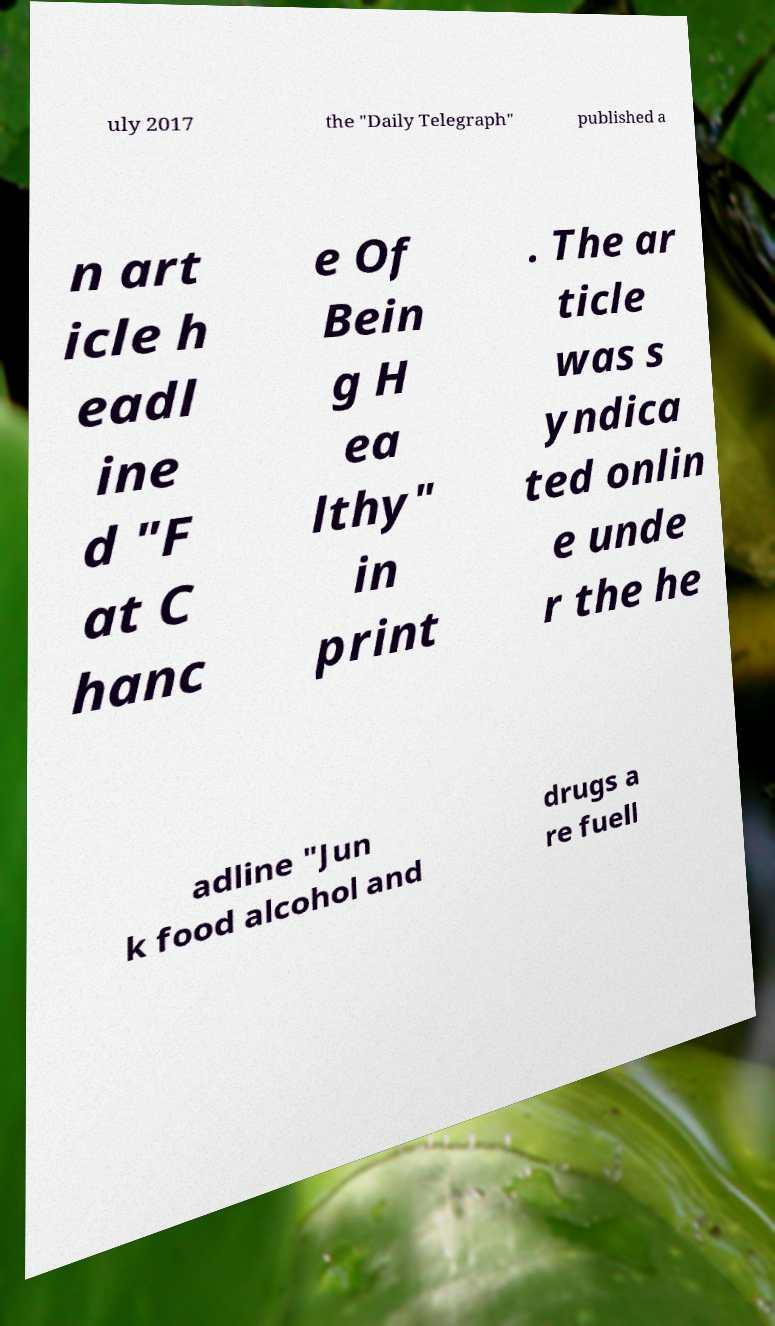Could you assist in decoding the text presented in this image and type it out clearly? uly 2017 the "Daily Telegraph" published a n art icle h eadl ine d "F at C hanc e Of Bein g H ea lthy" in print . The ar ticle was s yndica ted onlin e unde r the he adline "Jun k food alcohol and drugs a re fuell 